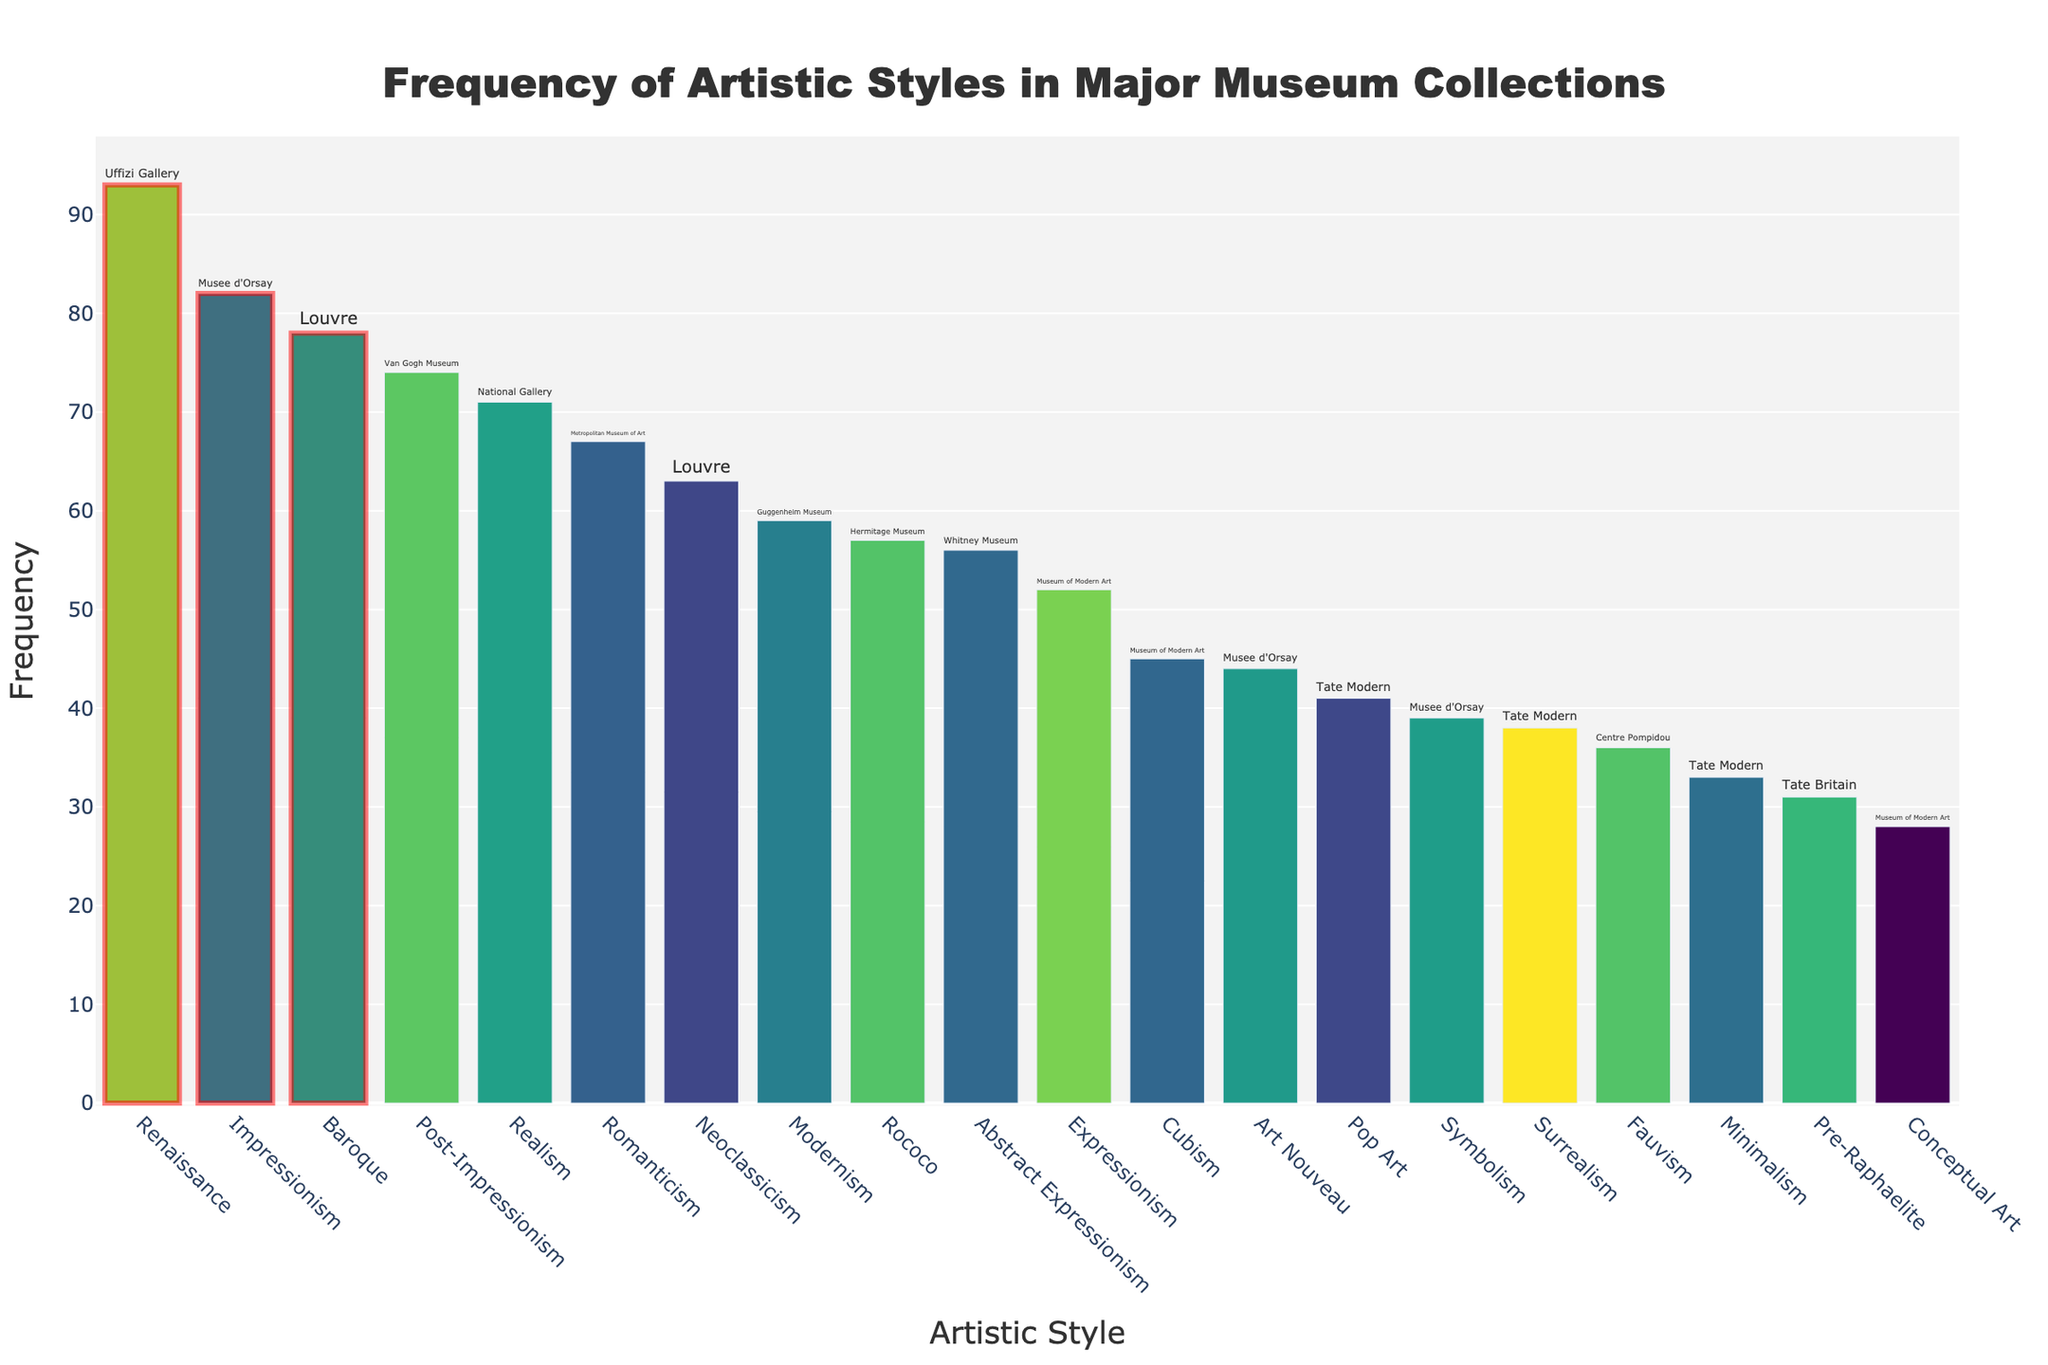What is the title of the plot? The title of the plot is displayed prominently at the top and provides a clear summary of what the graph is about. In this case, it explains that the plot is showing the frequency of different artistic styles in major museum collections.
Answer: Frequency of Artistic Styles in Major Museum Collections Which artistic style appears most frequently in the collections? By looking at the height of the bars, the tallest bar represents the most frequent artistic style. The style is listed along the x-axis.
Answer: Renaissance How many styles have a frequency above 70? By examining the y-axis to identify the bars that extend beyond the 70 mark and counting these bars, we get the total number of styles with a frequency above 70.
Answer: 5 What museums house the top three most frequent artistic styles? Hovering over or reading the text labels on the bars with the top three highest frequencies reveals the associated museums.
Answer: Uffizi Gallery, Musee d'Orsay, Van Gogh Museum Which artistic styles are highlighted with a rectangle? The highlighted bars are visually enclosed by a rectangular shape, indicating their significance or high frequency in this context. These are the top three artistic styles.
Answer: Renaissance, Impressionism, Post-Impressionism What is the difference in frequency between the most frequent and least frequent artistic styles? Identify the highest frequency (Renaissance at 93) and the lowest frequency (Conceptual Art at 28), then subtract the least from the most.
Answer: 65 Which artistic style has a frequency closest to 50? By examining the bars around the 50-mark on the y-axis, the most proximate bar to 50 can be identified.
Answer: Expressionism Are there any artistic styles with the same frequency? If yes, name them. Check if any bars reach the same height along the y-axis and confirm by comparing their values.
Answer: Yes, Pop Art and Neoclassicism both have a frequency of 63 Which museum has the most diverse collection in terms of represented artistic styles? Look at the museum labels in the hover text and count the distinct artistic styles associated with each museum. The one with the highest count is the most diverse.
Answer: Tate Modern What is the average frequency of the artistic styles in the collections? Sum the frequencies of all the artistic styles and divide by the total number of styles (20). (82+45+38+56+93+78+41+67+74+59+71+63+52+36+44+57+39+33+28+31)/20 = 934/20 = 46.7
Answer: 46.7 